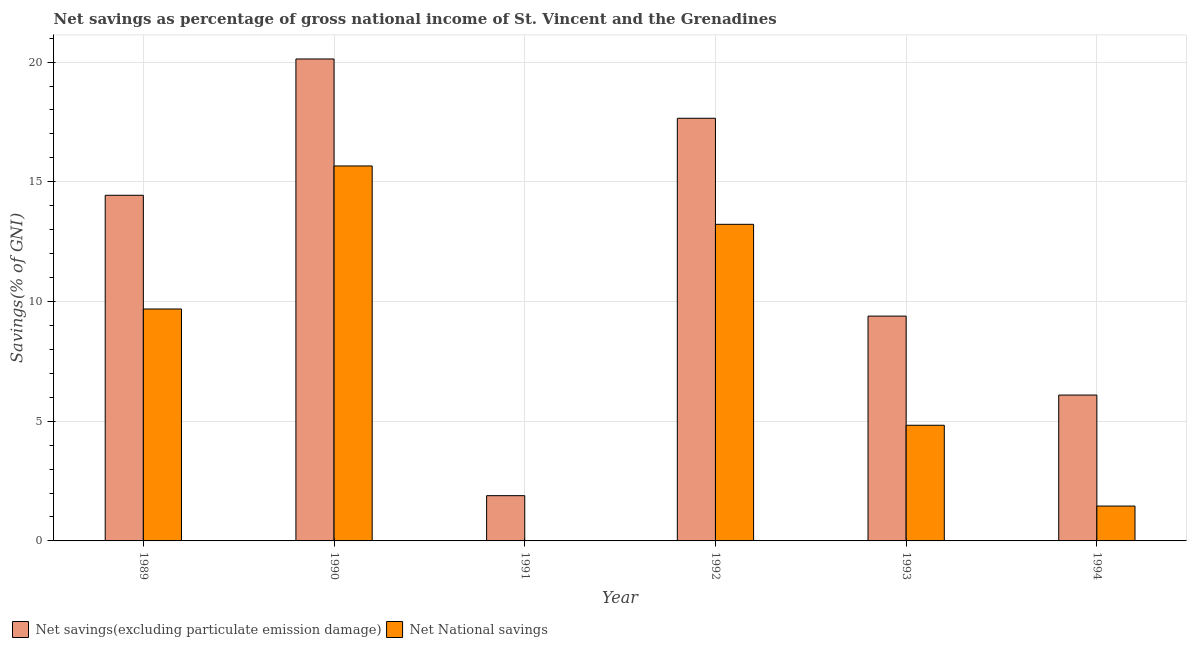How many different coloured bars are there?
Offer a terse response. 2. How many bars are there on the 6th tick from the left?
Provide a succinct answer. 2. What is the label of the 2nd group of bars from the left?
Your answer should be very brief. 1990. What is the net savings(excluding particulate emission damage) in 1989?
Make the answer very short. 14.44. Across all years, what is the maximum net savings(excluding particulate emission damage)?
Make the answer very short. 20.13. Across all years, what is the minimum net savings(excluding particulate emission damage)?
Offer a very short reply. 1.89. What is the total net savings(excluding particulate emission damage) in the graph?
Provide a succinct answer. 69.6. What is the difference between the net savings(excluding particulate emission damage) in 1989 and that in 1991?
Offer a terse response. 12.55. What is the difference between the net savings(excluding particulate emission damage) in 1989 and the net national savings in 1992?
Make the answer very short. -3.22. What is the average net national savings per year?
Your response must be concise. 7.48. What is the ratio of the net savings(excluding particulate emission damage) in 1990 to that in 1992?
Keep it short and to the point. 1.14. Is the difference between the net savings(excluding particulate emission damage) in 1991 and 1994 greater than the difference between the net national savings in 1991 and 1994?
Offer a very short reply. No. What is the difference between the highest and the second highest net savings(excluding particulate emission damage)?
Offer a very short reply. 2.48. What is the difference between the highest and the lowest net national savings?
Give a very brief answer. 15.66. In how many years, is the net savings(excluding particulate emission damage) greater than the average net savings(excluding particulate emission damage) taken over all years?
Offer a very short reply. 3. Are all the bars in the graph horizontal?
Provide a short and direct response. No. Are the values on the major ticks of Y-axis written in scientific E-notation?
Give a very brief answer. No. What is the title of the graph?
Give a very brief answer. Net savings as percentage of gross national income of St. Vincent and the Grenadines. What is the label or title of the X-axis?
Your answer should be compact. Year. What is the label or title of the Y-axis?
Offer a terse response. Savings(% of GNI). What is the Savings(% of GNI) of Net savings(excluding particulate emission damage) in 1989?
Your response must be concise. 14.44. What is the Savings(% of GNI) of Net National savings in 1989?
Your response must be concise. 9.69. What is the Savings(% of GNI) in Net savings(excluding particulate emission damage) in 1990?
Your answer should be very brief. 20.13. What is the Savings(% of GNI) of Net National savings in 1990?
Ensure brevity in your answer.  15.66. What is the Savings(% of GNI) of Net savings(excluding particulate emission damage) in 1991?
Your response must be concise. 1.89. What is the Savings(% of GNI) of Net savings(excluding particulate emission damage) in 1992?
Your answer should be compact. 17.65. What is the Savings(% of GNI) of Net National savings in 1992?
Offer a very short reply. 13.22. What is the Savings(% of GNI) in Net savings(excluding particulate emission damage) in 1993?
Offer a terse response. 9.39. What is the Savings(% of GNI) of Net National savings in 1993?
Provide a short and direct response. 4.83. What is the Savings(% of GNI) in Net savings(excluding particulate emission damage) in 1994?
Provide a succinct answer. 6.09. What is the Savings(% of GNI) of Net National savings in 1994?
Provide a succinct answer. 1.46. Across all years, what is the maximum Savings(% of GNI) in Net savings(excluding particulate emission damage)?
Offer a terse response. 20.13. Across all years, what is the maximum Savings(% of GNI) in Net National savings?
Keep it short and to the point. 15.66. Across all years, what is the minimum Savings(% of GNI) of Net savings(excluding particulate emission damage)?
Keep it short and to the point. 1.89. Across all years, what is the minimum Savings(% of GNI) in Net National savings?
Ensure brevity in your answer.  0. What is the total Savings(% of GNI) in Net savings(excluding particulate emission damage) in the graph?
Give a very brief answer. 69.6. What is the total Savings(% of GNI) in Net National savings in the graph?
Your answer should be very brief. 44.86. What is the difference between the Savings(% of GNI) in Net savings(excluding particulate emission damage) in 1989 and that in 1990?
Give a very brief answer. -5.69. What is the difference between the Savings(% of GNI) of Net National savings in 1989 and that in 1990?
Your answer should be very brief. -5.97. What is the difference between the Savings(% of GNI) of Net savings(excluding particulate emission damage) in 1989 and that in 1991?
Your response must be concise. 12.55. What is the difference between the Savings(% of GNI) in Net savings(excluding particulate emission damage) in 1989 and that in 1992?
Provide a short and direct response. -3.22. What is the difference between the Savings(% of GNI) of Net National savings in 1989 and that in 1992?
Ensure brevity in your answer.  -3.54. What is the difference between the Savings(% of GNI) in Net savings(excluding particulate emission damage) in 1989 and that in 1993?
Offer a very short reply. 5.05. What is the difference between the Savings(% of GNI) of Net National savings in 1989 and that in 1993?
Offer a terse response. 4.86. What is the difference between the Savings(% of GNI) of Net savings(excluding particulate emission damage) in 1989 and that in 1994?
Make the answer very short. 8.35. What is the difference between the Savings(% of GNI) of Net National savings in 1989 and that in 1994?
Offer a terse response. 8.23. What is the difference between the Savings(% of GNI) of Net savings(excluding particulate emission damage) in 1990 and that in 1991?
Make the answer very short. 18.24. What is the difference between the Savings(% of GNI) in Net savings(excluding particulate emission damage) in 1990 and that in 1992?
Offer a very short reply. 2.48. What is the difference between the Savings(% of GNI) of Net National savings in 1990 and that in 1992?
Ensure brevity in your answer.  2.44. What is the difference between the Savings(% of GNI) of Net savings(excluding particulate emission damage) in 1990 and that in 1993?
Keep it short and to the point. 10.74. What is the difference between the Savings(% of GNI) of Net National savings in 1990 and that in 1993?
Offer a very short reply. 10.83. What is the difference between the Savings(% of GNI) in Net savings(excluding particulate emission damage) in 1990 and that in 1994?
Your response must be concise. 14.04. What is the difference between the Savings(% of GNI) in Net National savings in 1990 and that in 1994?
Your response must be concise. 14.21. What is the difference between the Savings(% of GNI) of Net savings(excluding particulate emission damage) in 1991 and that in 1992?
Your response must be concise. -15.76. What is the difference between the Savings(% of GNI) in Net savings(excluding particulate emission damage) in 1991 and that in 1993?
Your answer should be very brief. -7.5. What is the difference between the Savings(% of GNI) in Net savings(excluding particulate emission damage) in 1991 and that in 1994?
Offer a terse response. -4.2. What is the difference between the Savings(% of GNI) in Net savings(excluding particulate emission damage) in 1992 and that in 1993?
Give a very brief answer. 8.26. What is the difference between the Savings(% of GNI) in Net National savings in 1992 and that in 1993?
Offer a terse response. 8.39. What is the difference between the Savings(% of GNI) of Net savings(excluding particulate emission damage) in 1992 and that in 1994?
Offer a very short reply. 11.56. What is the difference between the Savings(% of GNI) in Net National savings in 1992 and that in 1994?
Give a very brief answer. 11.77. What is the difference between the Savings(% of GNI) in Net savings(excluding particulate emission damage) in 1993 and that in 1994?
Your answer should be compact. 3.3. What is the difference between the Savings(% of GNI) of Net National savings in 1993 and that in 1994?
Ensure brevity in your answer.  3.37. What is the difference between the Savings(% of GNI) of Net savings(excluding particulate emission damage) in 1989 and the Savings(% of GNI) of Net National savings in 1990?
Your answer should be compact. -1.22. What is the difference between the Savings(% of GNI) of Net savings(excluding particulate emission damage) in 1989 and the Savings(% of GNI) of Net National savings in 1992?
Provide a succinct answer. 1.21. What is the difference between the Savings(% of GNI) in Net savings(excluding particulate emission damage) in 1989 and the Savings(% of GNI) in Net National savings in 1993?
Your answer should be compact. 9.61. What is the difference between the Savings(% of GNI) in Net savings(excluding particulate emission damage) in 1989 and the Savings(% of GNI) in Net National savings in 1994?
Ensure brevity in your answer.  12.98. What is the difference between the Savings(% of GNI) of Net savings(excluding particulate emission damage) in 1990 and the Savings(% of GNI) of Net National savings in 1992?
Your answer should be very brief. 6.91. What is the difference between the Savings(% of GNI) of Net savings(excluding particulate emission damage) in 1990 and the Savings(% of GNI) of Net National savings in 1993?
Offer a very short reply. 15.3. What is the difference between the Savings(% of GNI) of Net savings(excluding particulate emission damage) in 1990 and the Savings(% of GNI) of Net National savings in 1994?
Offer a very short reply. 18.67. What is the difference between the Savings(% of GNI) of Net savings(excluding particulate emission damage) in 1991 and the Savings(% of GNI) of Net National savings in 1992?
Offer a terse response. -11.33. What is the difference between the Savings(% of GNI) in Net savings(excluding particulate emission damage) in 1991 and the Savings(% of GNI) in Net National savings in 1993?
Offer a very short reply. -2.94. What is the difference between the Savings(% of GNI) of Net savings(excluding particulate emission damage) in 1991 and the Savings(% of GNI) of Net National savings in 1994?
Offer a terse response. 0.43. What is the difference between the Savings(% of GNI) of Net savings(excluding particulate emission damage) in 1992 and the Savings(% of GNI) of Net National savings in 1993?
Provide a short and direct response. 12.82. What is the difference between the Savings(% of GNI) of Net savings(excluding particulate emission damage) in 1992 and the Savings(% of GNI) of Net National savings in 1994?
Your answer should be very brief. 16.2. What is the difference between the Savings(% of GNI) of Net savings(excluding particulate emission damage) in 1993 and the Savings(% of GNI) of Net National savings in 1994?
Keep it short and to the point. 7.93. What is the average Savings(% of GNI) of Net savings(excluding particulate emission damage) per year?
Your answer should be very brief. 11.6. What is the average Savings(% of GNI) in Net National savings per year?
Offer a very short reply. 7.48. In the year 1989, what is the difference between the Savings(% of GNI) of Net savings(excluding particulate emission damage) and Savings(% of GNI) of Net National savings?
Your answer should be very brief. 4.75. In the year 1990, what is the difference between the Savings(% of GNI) in Net savings(excluding particulate emission damage) and Savings(% of GNI) in Net National savings?
Ensure brevity in your answer.  4.47. In the year 1992, what is the difference between the Savings(% of GNI) in Net savings(excluding particulate emission damage) and Savings(% of GNI) in Net National savings?
Your response must be concise. 4.43. In the year 1993, what is the difference between the Savings(% of GNI) of Net savings(excluding particulate emission damage) and Savings(% of GNI) of Net National savings?
Give a very brief answer. 4.56. In the year 1994, what is the difference between the Savings(% of GNI) in Net savings(excluding particulate emission damage) and Savings(% of GNI) in Net National savings?
Provide a short and direct response. 4.64. What is the ratio of the Savings(% of GNI) of Net savings(excluding particulate emission damage) in 1989 to that in 1990?
Your response must be concise. 0.72. What is the ratio of the Savings(% of GNI) of Net National savings in 1989 to that in 1990?
Provide a short and direct response. 0.62. What is the ratio of the Savings(% of GNI) of Net savings(excluding particulate emission damage) in 1989 to that in 1991?
Offer a very short reply. 7.64. What is the ratio of the Savings(% of GNI) in Net savings(excluding particulate emission damage) in 1989 to that in 1992?
Your answer should be very brief. 0.82. What is the ratio of the Savings(% of GNI) of Net National savings in 1989 to that in 1992?
Your response must be concise. 0.73. What is the ratio of the Savings(% of GNI) in Net savings(excluding particulate emission damage) in 1989 to that in 1993?
Give a very brief answer. 1.54. What is the ratio of the Savings(% of GNI) of Net National savings in 1989 to that in 1993?
Offer a very short reply. 2.01. What is the ratio of the Savings(% of GNI) of Net savings(excluding particulate emission damage) in 1989 to that in 1994?
Give a very brief answer. 2.37. What is the ratio of the Savings(% of GNI) of Net National savings in 1989 to that in 1994?
Keep it short and to the point. 6.65. What is the ratio of the Savings(% of GNI) of Net savings(excluding particulate emission damage) in 1990 to that in 1991?
Your response must be concise. 10.65. What is the ratio of the Savings(% of GNI) of Net savings(excluding particulate emission damage) in 1990 to that in 1992?
Give a very brief answer. 1.14. What is the ratio of the Savings(% of GNI) of Net National savings in 1990 to that in 1992?
Provide a succinct answer. 1.18. What is the ratio of the Savings(% of GNI) of Net savings(excluding particulate emission damage) in 1990 to that in 1993?
Provide a short and direct response. 2.14. What is the ratio of the Savings(% of GNI) in Net National savings in 1990 to that in 1993?
Make the answer very short. 3.24. What is the ratio of the Savings(% of GNI) in Net savings(excluding particulate emission damage) in 1990 to that in 1994?
Ensure brevity in your answer.  3.3. What is the ratio of the Savings(% of GNI) of Net National savings in 1990 to that in 1994?
Give a very brief answer. 10.75. What is the ratio of the Savings(% of GNI) in Net savings(excluding particulate emission damage) in 1991 to that in 1992?
Keep it short and to the point. 0.11. What is the ratio of the Savings(% of GNI) of Net savings(excluding particulate emission damage) in 1991 to that in 1993?
Ensure brevity in your answer.  0.2. What is the ratio of the Savings(% of GNI) in Net savings(excluding particulate emission damage) in 1991 to that in 1994?
Your response must be concise. 0.31. What is the ratio of the Savings(% of GNI) of Net savings(excluding particulate emission damage) in 1992 to that in 1993?
Ensure brevity in your answer.  1.88. What is the ratio of the Savings(% of GNI) in Net National savings in 1992 to that in 1993?
Provide a succinct answer. 2.74. What is the ratio of the Savings(% of GNI) in Net savings(excluding particulate emission damage) in 1992 to that in 1994?
Keep it short and to the point. 2.9. What is the ratio of the Savings(% of GNI) in Net National savings in 1992 to that in 1994?
Offer a terse response. 9.08. What is the ratio of the Savings(% of GNI) in Net savings(excluding particulate emission damage) in 1993 to that in 1994?
Ensure brevity in your answer.  1.54. What is the ratio of the Savings(% of GNI) in Net National savings in 1993 to that in 1994?
Your answer should be compact. 3.32. What is the difference between the highest and the second highest Savings(% of GNI) of Net savings(excluding particulate emission damage)?
Your response must be concise. 2.48. What is the difference between the highest and the second highest Savings(% of GNI) of Net National savings?
Provide a short and direct response. 2.44. What is the difference between the highest and the lowest Savings(% of GNI) of Net savings(excluding particulate emission damage)?
Make the answer very short. 18.24. What is the difference between the highest and the lowest Savings(% of GNI) of Net National savings?
Your response must be concise. 15.66. 